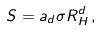<formula> <loc_0><loc_0><loc_500><loc_500>S = a _ { d } \sigma R _ { H } ^ { d } \, ,</formula> 